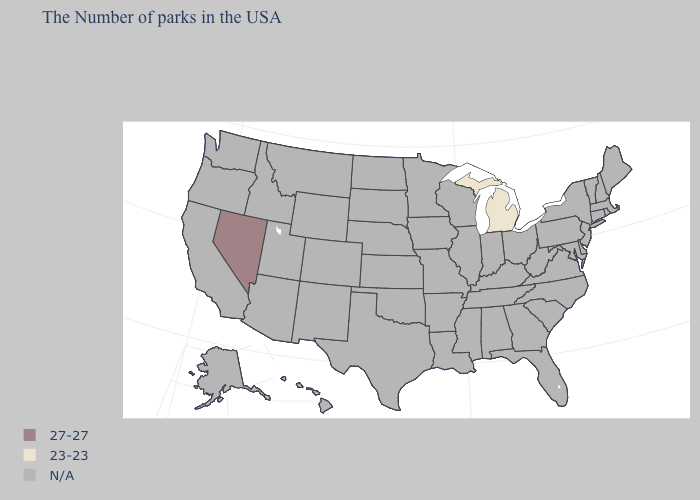Which states have the highest value in the USA?
Concise answer only. Nevada. Name the states that have a value in the range 23-23?
Keep it brief. Michigan. Among the states that border Indiana , which have the lowest value?
Be succinct. Michigan. Name the states that have a value in the range 27-27?
Give a very brief answer. Nevada. How many symbols are there in the legend?
Answer briefly. 3. What is the value of New Hampshire?
Give a very brief answer. N/A. How many symbols are there in the legend?
Write a very short answer. 3. Is the legend a continuous bar?
Write a very short answer. No. What is the value of Maine?
Answer briefly. N/A. 